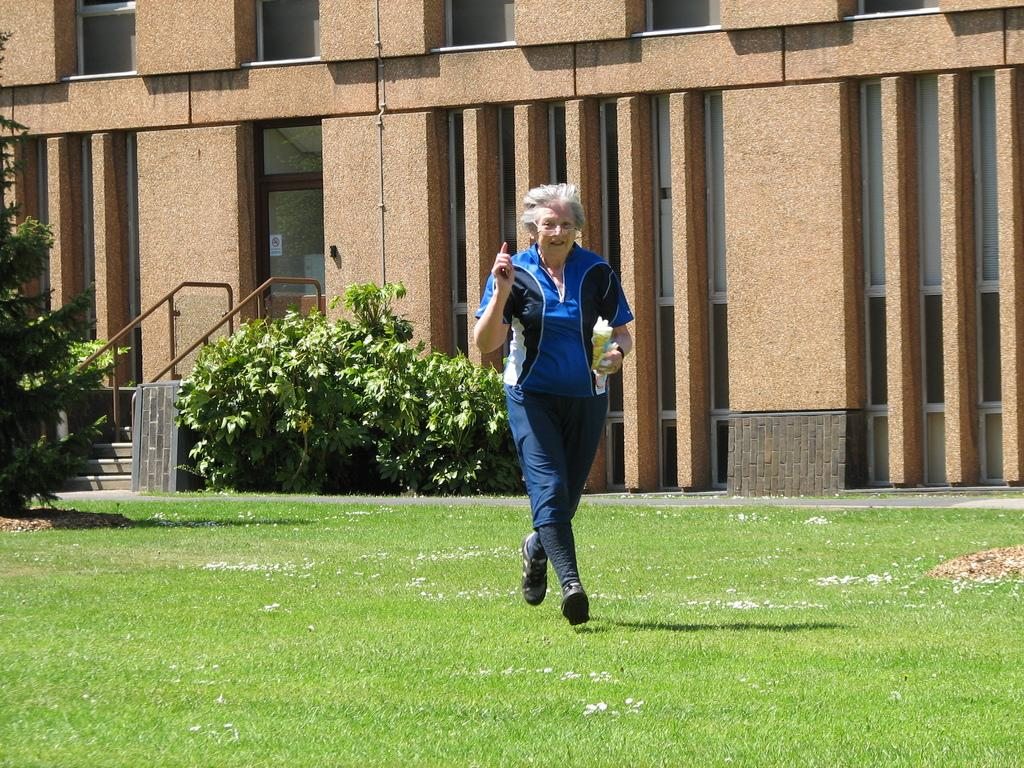What is the person in the image doing? The person is running on the grass in the image. What is the person holding while running? The person is holding an object in the image. What type of vegetation can be seen in the image? There are plants and a tree visible in the image. What architectural feature is present in the image? There is a stairway with handrails in the image. What type of structure is in the background of the image? There is a building in the image. How many pumpkins are hanging from the tree in the image? There are no pumpkins visible in the image, and there is no tree with hanging objects. 